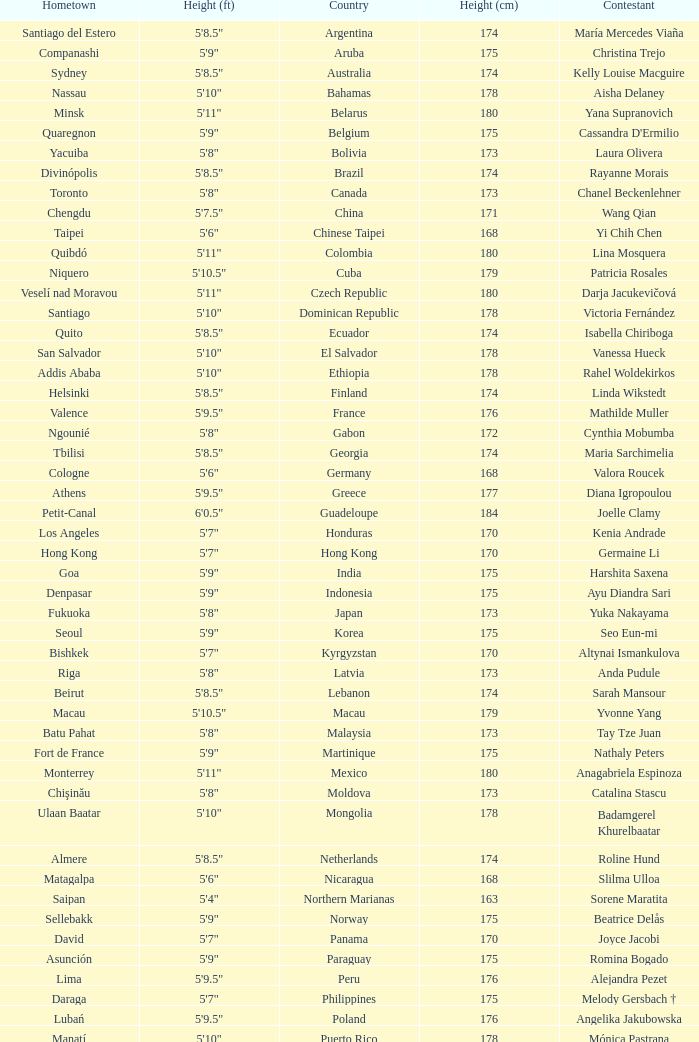What is Cynthia Mobumba's height? 5'8". 